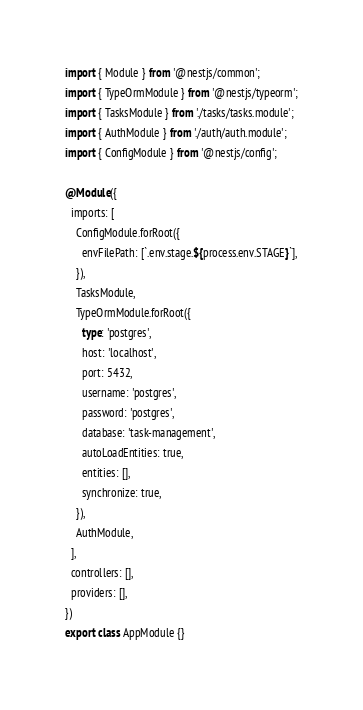<code> <loc_0><loc_0><loc_500><loc_500><_TypeScript_>import { Module } from '@nestjs/common';
import { TypeOrmModule } from '@nestjs/typeorm';
import { TasksModule } from './tasks/tasks.module';
import { AuthModule } from './auth/auth.module';
import { ConfigModule } from '@nestjs/config';

@Module({
  imports: [
    ConfigModule.forRoot({
      envFilePath: [`.env.stage.${process.env.STAGE}`],
    }),
    TasksModule,
    TypeOrmModule.forRoot({
      type: 'postgres',
      host: 'localhost',
      port: 5432,
      username: 'postgres',
      password: 'postgres',
      database: 'task-management',
      autoLoadEntities: true,
      entities: [],
      synchronize: true,
    }),
    AuthModule,
  ],
  controllers: [],
  providers: [],
})
export class AppModule {}
</code> 